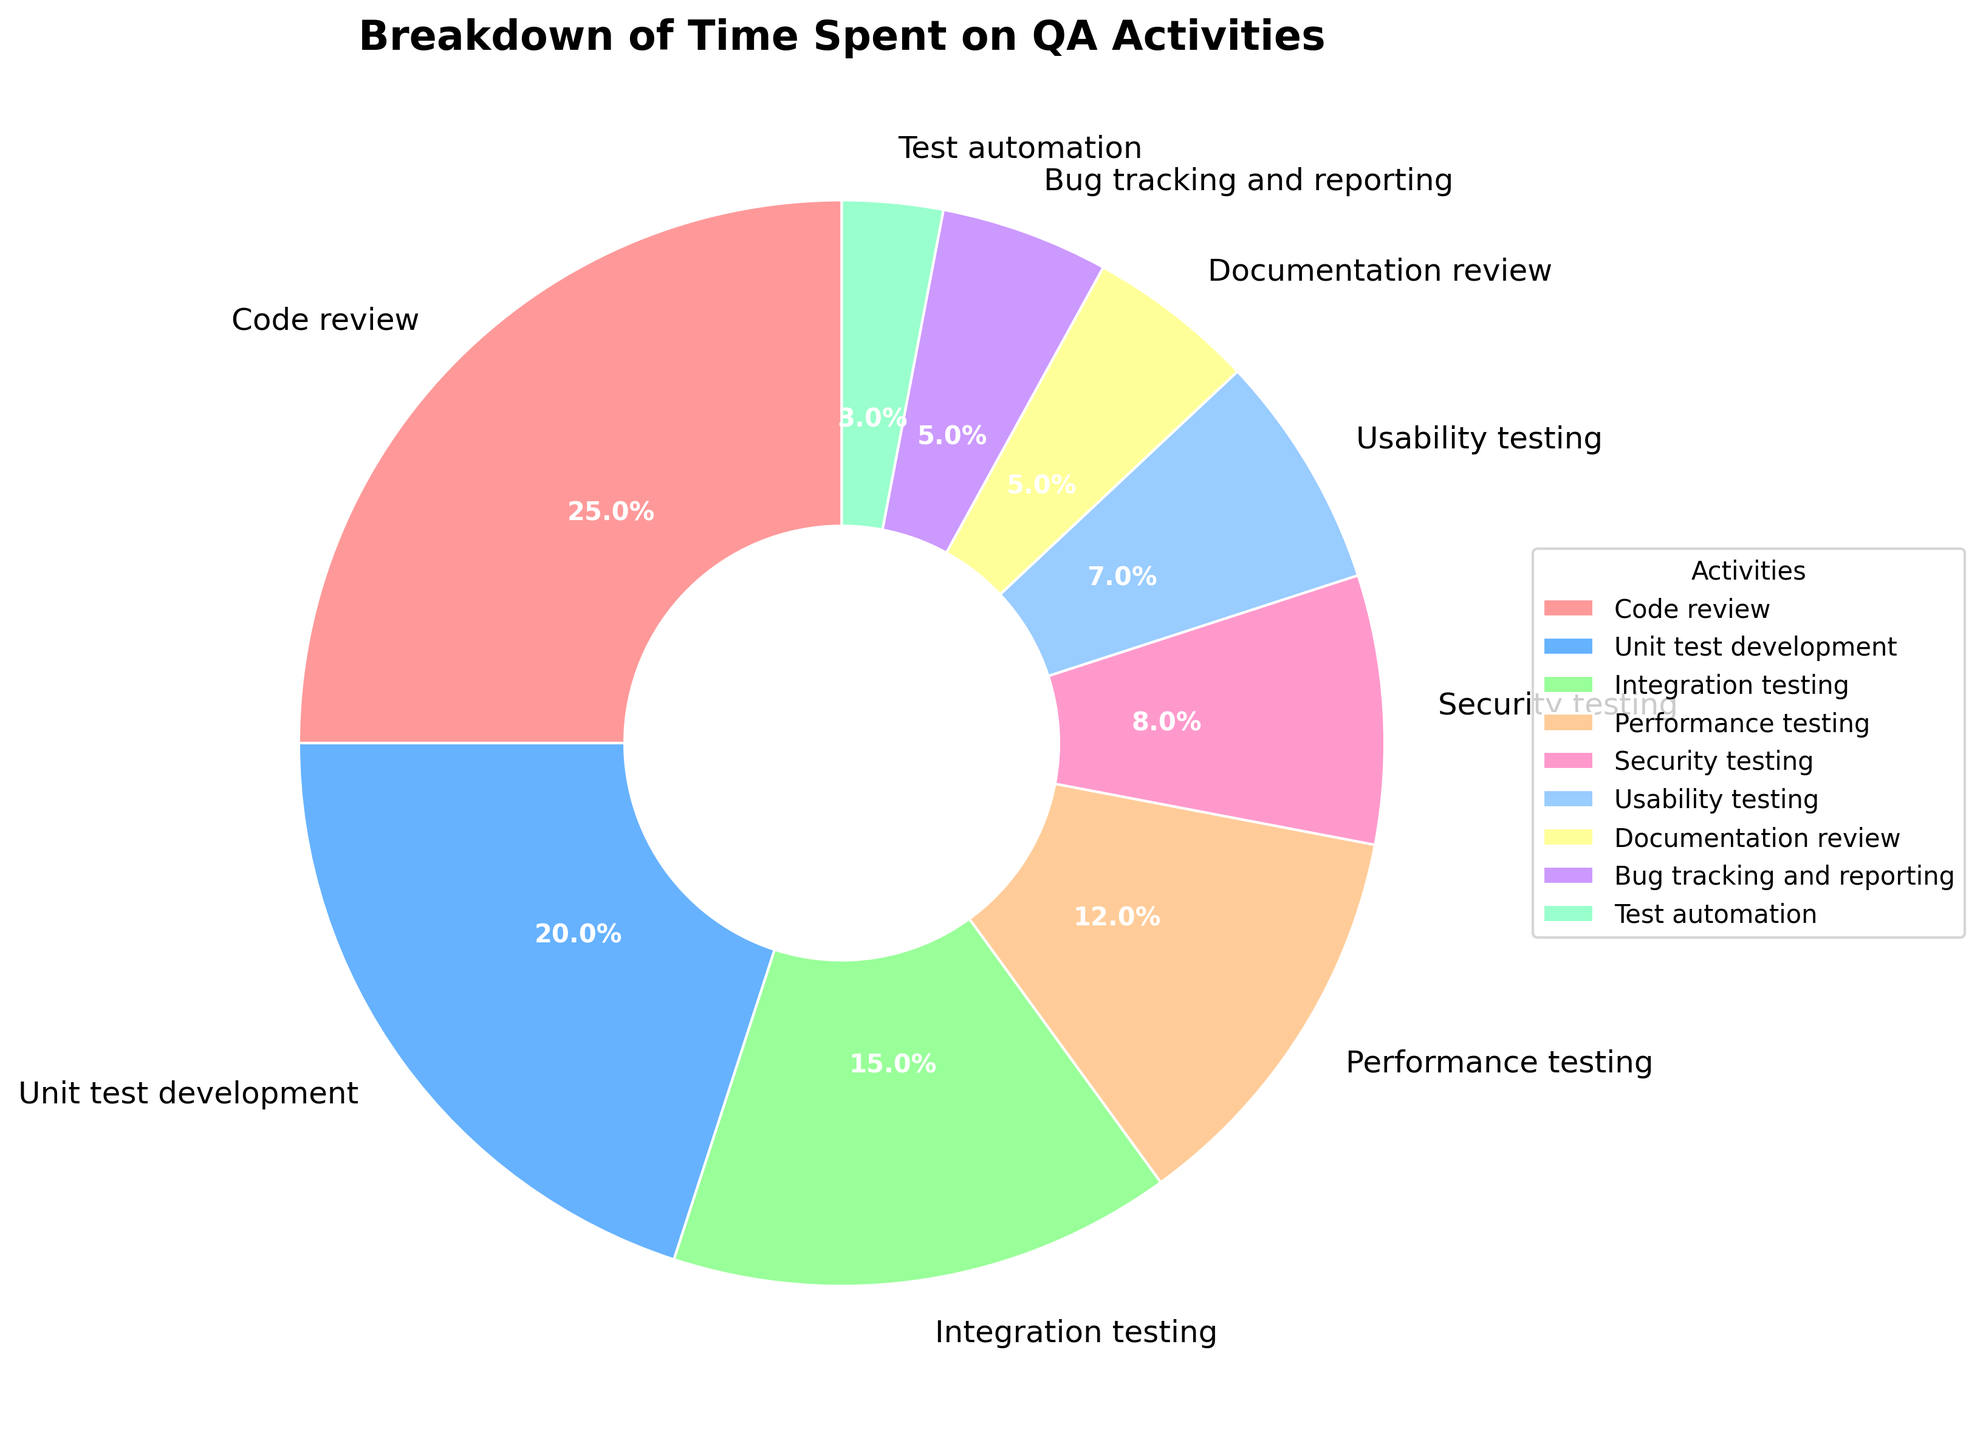What's the largest activity or category in terms of time spent? To find the largest activity, look at the slice with the biggest area and then refer to the label next to it. "Code review" has the largest slice at 25%.
Answer: Code review How much time is spent on both Unit test development and Integration testing combined? From the chart, Unit test development consumes 20% and Integration testing 15%. Adding them together, 20% + 15% = 35%.
Answer: 35% Which two activities take up an equal amount of time? Look for slices of the same size and check their labels. "Documentation review" and "Bug tracking and reporting" each take up 5%.
Answer: Documentation review and Bug tracking and reporting Is more time spent on Security testing or Performance testing? Compare the slices for "Security testing" and "Performance testing". Security testing is 8% while Performance testing is 12%.
Answer: Performance testing What percentage of time is dedicated to activities other than Code review? Code review occupies 25%, so subtract this from 100%. 100% - 25% = 75%.
Answer: 75% What's the difference in time spent between Performance testing and Usability testing? Look at the percentages for Performance testing (12%) and Usability testing (7%), and subtract the smaller from the larger: 12% - 7% = 5%.
Answer: 5% What are the two least time-consuming activities, and how much time do they take together? The smallest slices represent activities with 3% ("Test automation") and 5% ("Documentation review" and "Bug tracking and reporting"). Adding 3% and one of the 5% gives 8%.
Answer: Test automation and Documentation review or Bug tracking and reporting, 8% Which activity is represented by the blue-colored slice? Identify the blue slice visually and check the corresponding label, which is "Unit test development".
Answer: Unit test development How many activities take up more than 10% of the time each? Count the number of slices that represent more than 10%. They are "Code review" (25%), "Unit test development" (20%), and "Performance testing" (12%) – totaling three activities.
Answer: 3 If the percentage for "Bug tracking and reporting" was doubled, how would it compare to "Integration testing"? Currently, "Bug tracking and reporting" is 5%. Doubling it gives 10%. "Integration testing" is 15%. 10% < 15%, so it would still be less.
Answer: Less 